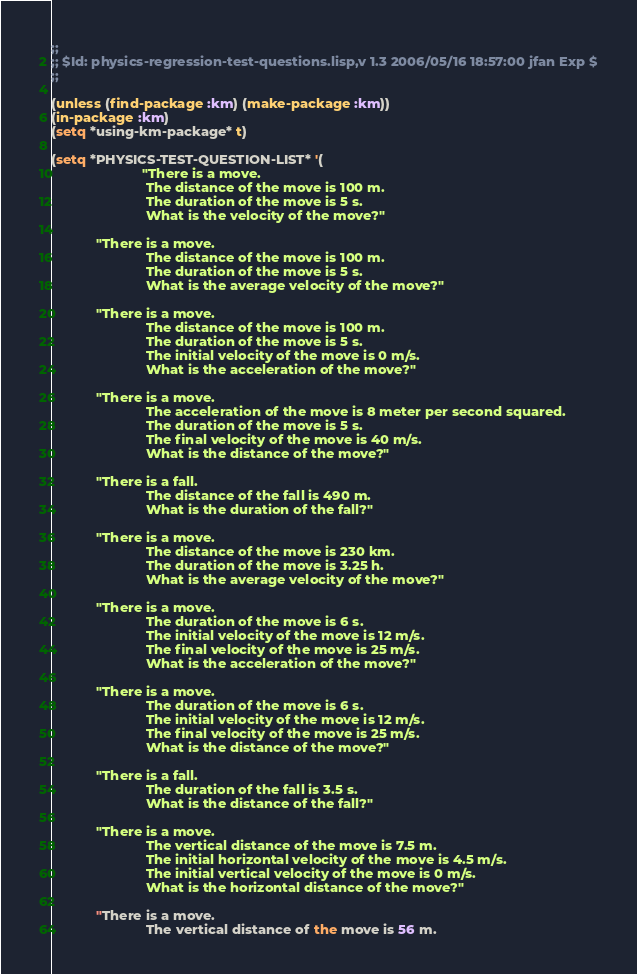<code> <loc_0><loc_0><loc_500><loc_500><_Lisp_>;;
;; $Id: physics-regression-test-questions.lisp,v 1.3 2006/05/16 18:57:00 jfan Exp $
;;

(unless (find-package :km) (make-package :km))
(in-package :km)
(setq *using-km-package* t)

(setq *PHYSICS-TEST-QUESTION-LIST* '(				     
                        "There is a move.
                         The distance of the move is 100 m.
                         The duration of the move is 5 s.
                         What is the velocity of the move?"

			"There is a move.
                         The distance of the move is 100 m.
                         The duration of the move is 5 s.
                         What is the average velocity of the move?"

			"There is a move.
                         The distance of the move is 100 m.
                         The duration of the move is 5 s.
                         The initial velocity of the move is 0 m/s.
                         What is the acceleration of the move?"

			"There is a move.
                         The acceleration of the move is 8 meter per second squared.
                         The duration of the move is 5 s.
                         The final velocity of the move is 40 m/s.
                         What is the distance of the move?"

			"There is a fall.
                         The distance of the fall is 490 m.
                         What is the duration of the fall?"

			"There is a move.
                         The distance of the move is 230 km.
                         The duration of the move is 3.25 h.
                         What is the average velocity of the move?"

			"There is a move.
                         The duration of the move is 6 s.
                         The initial velocity of the move is 12 m/s.
                         The final velocity of the move is 25 m/s.
                         What is the acceleration of the move?"

			"There is a move.
                         The duration of the move is 6 s.
                         The initial velocity of the move is 12 m/s.
                         The final velocity of the move is 25 m/s.
                         What is the distance of the move?"

			"There is a fall.
                         The duration of the fall is 3.5 s.
                         What is the distance of the fall?"

			"There is a move.
                         The vertical distance of the move is 7.5 m.
                         The initial horizontal velocity of the move is 4.5 m/s.
                         The initial vertical velocity of the move is 0 m/s.
                         What is the horizontal distance of the move?"

			"There is a move.
                         The vertical distance of the move is 56 m.</code> 